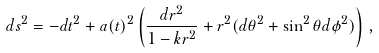Convert formula to latex. <formula><loc_0><loc_0><loc_500><loc_500>d s ^ { 2 } = - d t ^ { 2 } + a ( t ) ^ { 2 } \left ( \frac { d r ^ { 2 } } { 1 - k r ^ { 2 } } + r ^ { 2 } ( d \theta ^ { 2 } + \sin ^ { 2 } \theta d \phi ^ { 2 } ) \right ) \, ,</formula> 